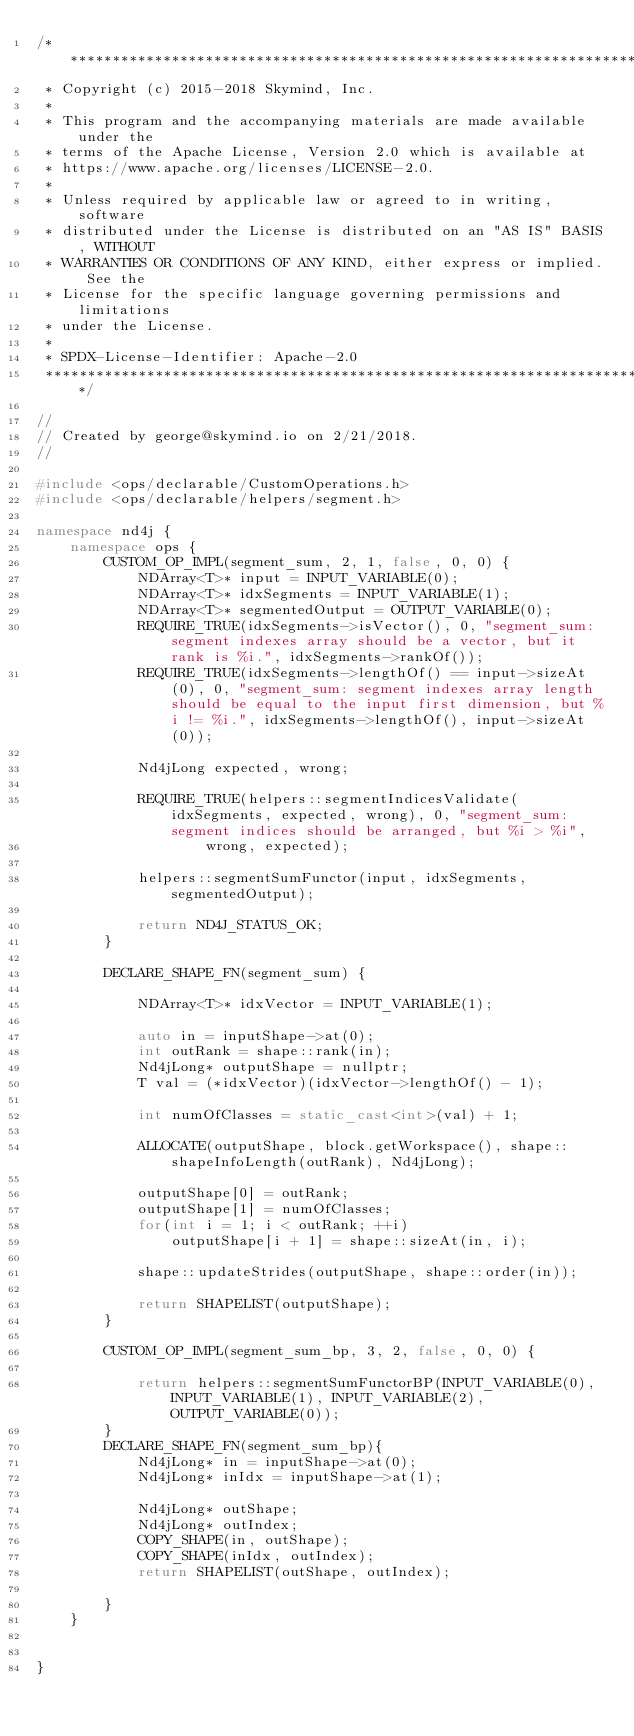<code> <loc_0><loc_0><loc_500><loc_500><_C++_>/*******************************************************************************
 * Copyright (c) 2015-2018 Skymind, Inc.
 *
 * This program and the accompanying materials are made available under the
 * terms of the Apache License, Version 2.0 which is available at
 * https://www.apache.org/licenses/LICENSE-2.0.
 *
 * Unless required by applicable law or agreed to in writing, software
 * distributed under the License is distributed on an "AS IS" BASIS, WITHOUT
 * WARRANTIES OR CONDITIONS OF ANY KIND, either express or implied. See the
 * License for the specific language governing permissions and limitations
 * under the License.
 *
 * SPDX-License-Identifier: Apache-2.0
 ******************************************************************************/

//
// Created by george@skymind.io on 2/21/2018.
//

#include <ops/declarable/CustomOperations.h>
#include <ops/declarable/helpers/segment.h>

namespace nd4j {
    namespace ops {
        CUSTOM_OP_IMPL(segment_sum, 2, 1, false, 0, 0) {
            NDArray<T>* input = INPUT_VARIABLE(0);
            NDArray<T>* idxSegments = INPUT_VARIABLE(1);
            NDArray<T>* segmentedOutput = OUTPUT_VARIABLE(0);
            REQUIRE_TRUE(idxSegments->isVector(), 0, "segment_sum: segment indexes array should be a vector, but it rank is %i.", idxSegments->rankOf());
            REQUIRE_TRUE(idxSegments->lengthOf() == input->sizeAt(0), 0, "segment_sum: segment indexes array length should be equal to the input first dimension, but %i != %i.", idxSegments->lengthOf(), input->sizeAt(0));

            Nd4jLong expected, wrong;

            REQUIRE_TRUE(helpers::segmentIndicesValidate(idxSegments, expected, wrong), 0, "segment_sum: segment indices should be arranged, but %i > %i",
                    wrong, expected);

            helpers::segmentSumFunctor(input, idxSegments, segmentedOutput);

            return ND4J_STATUS_OK;
        }

        DECLARE_SHAPE_FN(segment_sum) {

            NDArray<T>* idxVector = INPUT_VARIABLE(1);

            auto in = inputShape->at(0);
            int outRank = shape::rank(in);
            Nd4jLong* outputShape = nullptr;
            T val = (*idxVector)(idxVector->lengthOf() - 1);

            int numOfClasses = static_cast<int>(val) + 1;

            ALLOCATE(outputShape, block.getWorkspace(), shape::shapeInfoLength(outRank), Nd4jLong);

            outputShape[0] = outRank;
            outputShape[1] = numOfClasses;
            for(int i = 1; i < outRank; ++i)
                outputShape[i + 1] = shape::sizeAt(in, i);

            shape::updateStrides(outputShape, shape::order(in));

            return SHAPELIST(outputShape);
        }

        CUSTOM_OP_IMPL(segment_sum_bp, 3, 2, false, 0, 0) {

            return helpers::segmentSumFunctorBP(INPUT_VARIABLE(0), INPUT_VARIABLE(1), INPUT_VARIABLE(2), OUTPUT_VARIABLE(0));
        }
        DECLARE_SHAPE_FN(segment_sum_bp){
            Nd4jLong* in = inputShape->at(0);
            Nd4jLong* inIdx = inputShape->at(1);

            Nd4jLong* outShape;
            Nd4jLong* outIndex;
            COPY_SHAPE(in, outShape);
            COPY_SHAPE(inIdx, outIndex);
            return SHAPELIST(outShape, outIndex);

        }
    }


}
</code> 